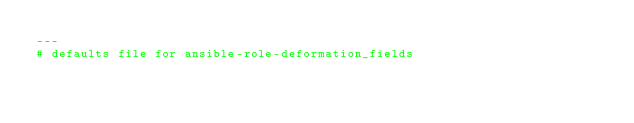Convert code to text. <code><loc_0><loc_0><loc_500><loc_500><_YAML_>---
# defaults file for ansible-role-deformation_fields
</code> 